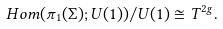<formula> <loc_0><loc_0><loc_500><loc_500>H o m ( \pi _ { 1 } ( \Sigma ) ; U ( 1 ) ) / U ( 1 ) \cong T ^ { 2 g } .</formula> 